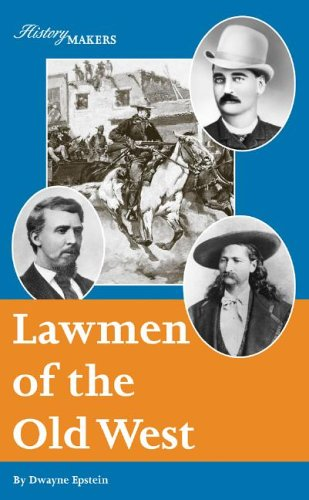What type of book is this? This is a Teen & Young Adult book, specifically designed to engage younger readers with captivating tales and important historical lessons about the Old West. 